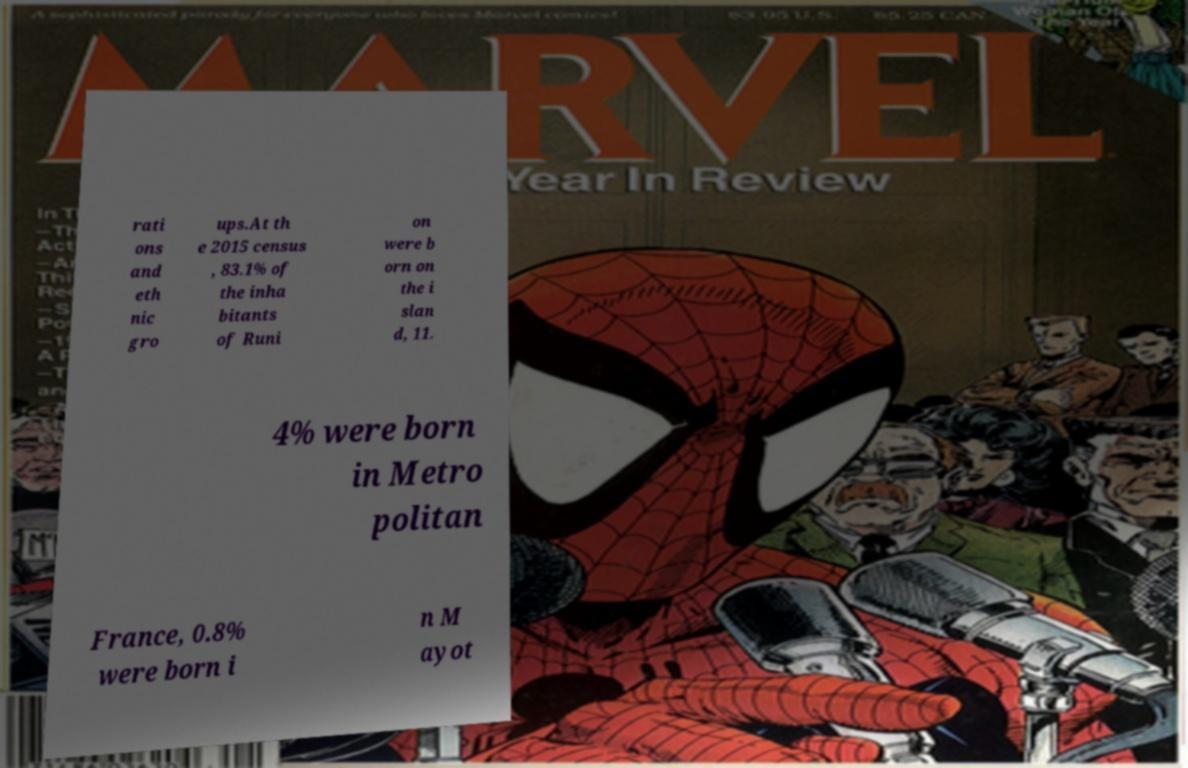Can you read and provide the text displayed in the image?This photo seems to have some interesting text. Can you extract and type it out for me? rati ons and eth nic gro ups.At th e 2015 census , 83.1% of the inha bitants of Runi on were b orn on the i slan d, 11. 4% were born in Metro politan France, 0.8% were born i n M ayot 